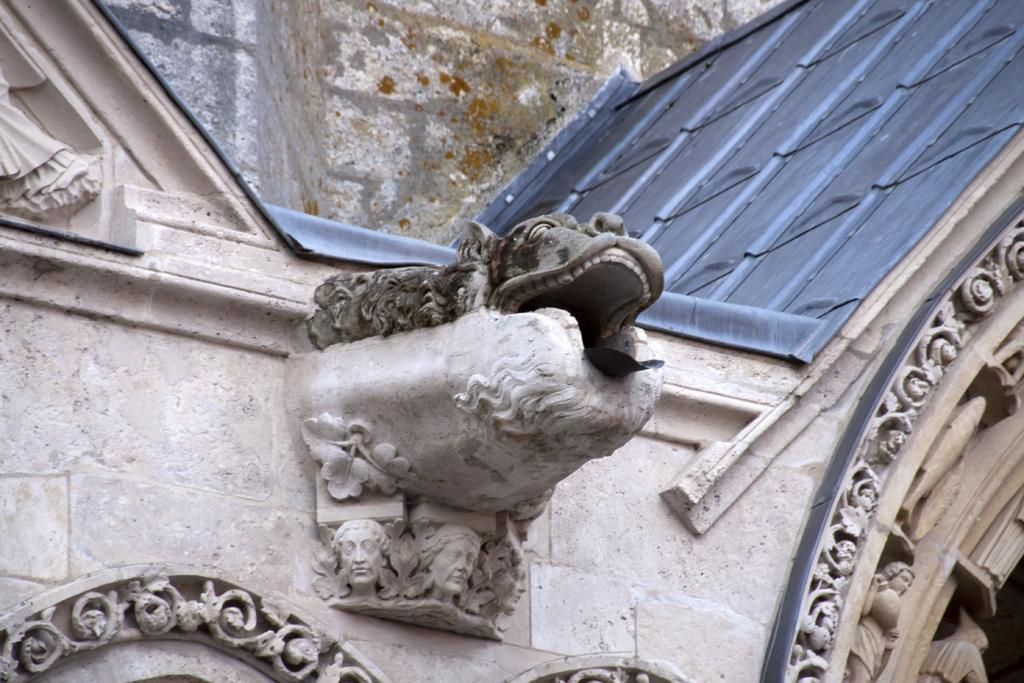Where was the image taken? The image is taken outdoors. What can be seen in the background of the image? There is a wall in the image. What decorations are present on the wall? The wall has sculptures and carvings on it. How many eggs are hidden in the carvings on the wall? There are no eggs present in the image, as it features a wall with sculptures and carvings, but no eggs. 